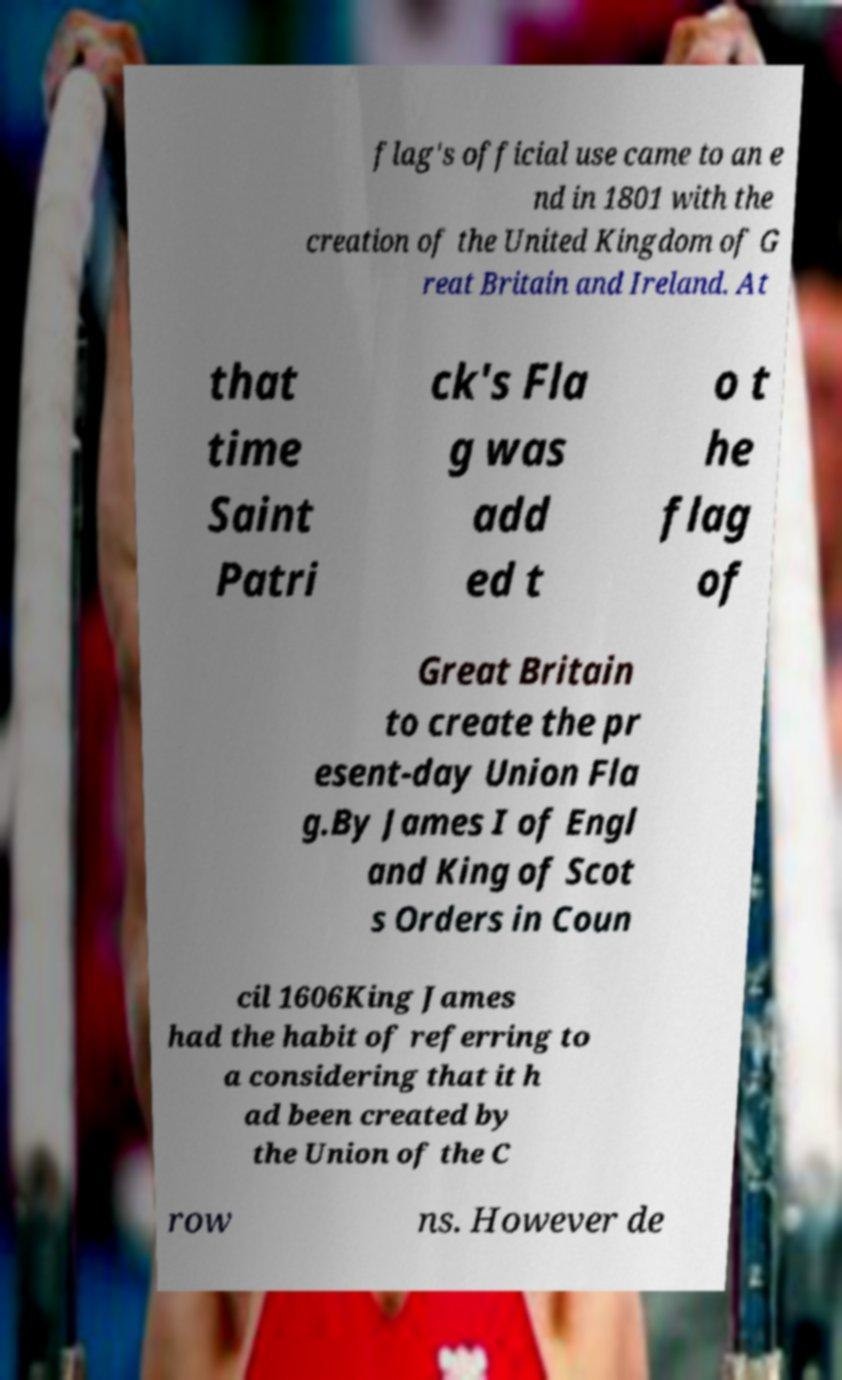Please identify and transcribe the text found in this image. flag's official use came to an e nd in 1801 with the creation of the United Kingdom of G reat Britain and Ireland. At that time Saint Patri ck's Fla g was add ed t o t he flag of Great Britain to create the pr esent-day Union Fla g.By James I of Engl and King of Scot s Orders in Coun cil 1606King James had the habit of referring to a considering that it h ad been created by the Union of the C row ns. However de 